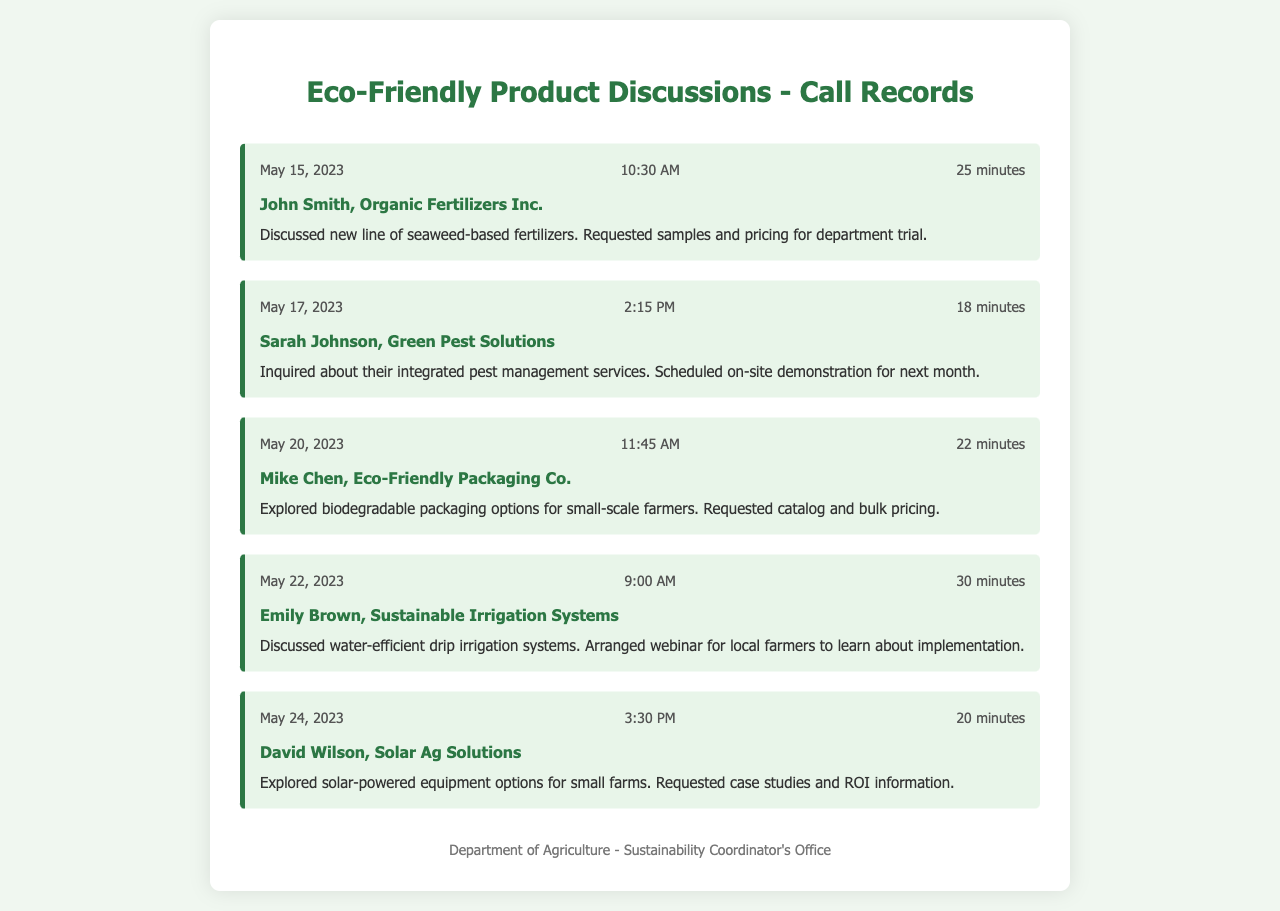What is the date of the call with John Smith? The date can be found in the call record section for John Smith, which states May 15, 2023.
Answer: May 15, 2023 How long was the call with Sarah Johnson? The duration of the call with Sarah Johnson is indicated as 18 minutes in the call record.
Answer: 18 minutes What type of product was discussed during the call with Mike Chen? The call record summarizes a discussion about biodegradable packaging options, highlighting the product type discussed.
Answer: Biodegradable packaging When is the scheduled on-site demonstration with Sarah Johnson? The document mentions that the on-site demonstration was scheduled for next month, which would be the month after the call date.
Answer: Next month Who was the contact for the discussion on sustainable irrigation systems? The call record identifies Emily Brown as the contact person for the discussion on sustainable irrigation systems.
Answer: Emily Brown What were the case studies requested from David Wilson about? The call summary with David Wilson mentions solar-powered equipment options as the focus of the request for case studies.
Answer: Solar-powered equipment What type of fertilizer was discussed in the conversation with John Smith? The call record specifies that the conversation was about seaweed-based fertilizers, detailing the type of fertilizer discussed.
Answer: Seaweed-based fertilizers How many minutes did the call with Emily Brown last? The duration of the call with Emily Brown is provided as 30 minutes in the document.
Answer: 30 minutes 